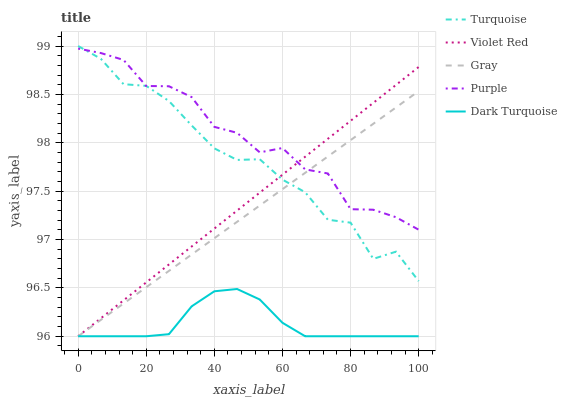Does Dark Turquoise have the minimum area under the curve?
Answer yes or no. Yes. Does Purple have the maximum area under the curve?
Answer yes or no. Yes. Does Gray have the minimum area under the curve?
Answer yes or no. No. Does Gray have the maximum area under the curve?
Answer yes or no. No. Is Gray the smoothest?
Answer yes or no. Yes. Is Turquoise the roughest?
Answer yes or no. Yes. Is Turquoise the smoothest?
Answer yes or no. No. Is Gray the roughest?
Answer yes or no. No. Does Gray have the lowest value?
Answer yes or no. Yes. Does Turquoise have the lowest value?
Answer yes or no. No. Does Turquoise have the highest value?
Answer yes or no. Yes. Does Gray have the highest value?
Answer yes or no. No. Is Dark Turquoise less than Purple?
Answer yes or no. Yes. Is Turquoise greater than Dark Turquoise?
Answer yes or no. Yes. Does Turquoise intersect Purple?
Answer yes or no. Yes. Is Turquoise less than Purple?
Answer yes or no. No. Is Turquoise greater than Purple?
Answer yes or no. No. Does Dark Turquoise intersect Purple?
Answer yes or no. No. 